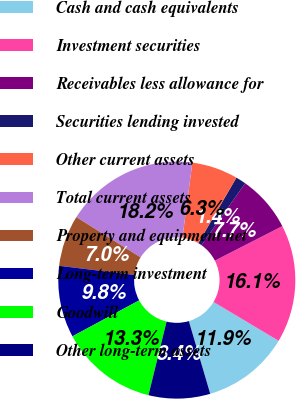<chart> <loc_0><loc_0><loc_500><loc_500><pie_chart><fcel>Cash and cash equivalents<fcel>Investment securities<fcel>Receivables less allowance for<fcel>Securities lending invested<fcel>Other current assets<fcel>Total current assets<fcel>Property and equipment net<fcel>Long-term investment<fcel>Goodwill<fcel>Other long-term assets<nl><fcel>11.89%<fcel>16.08%<fcel>7.69%<fcel>1.4%<fcel>6.29%<fcel>18.18%<fcel>6.99%<fcel>9.79%<fcel>13.29%<fcel>8.39%<nl></chart> 